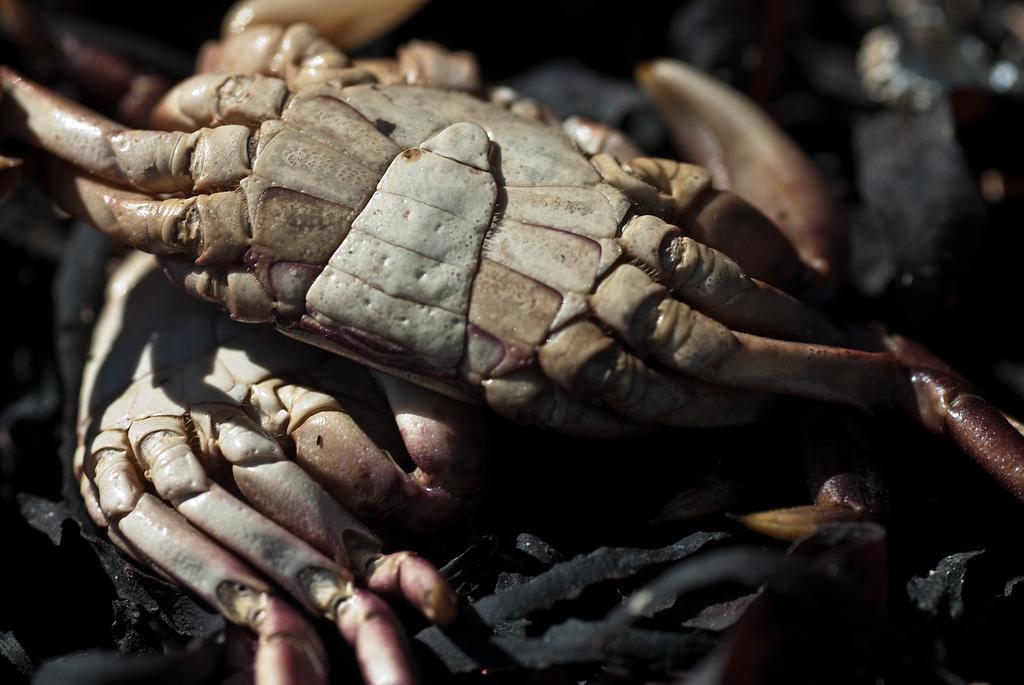Please provide a concise description of this image. In this image we can see two crabs, some black objects on the ground and the background is blurred. 